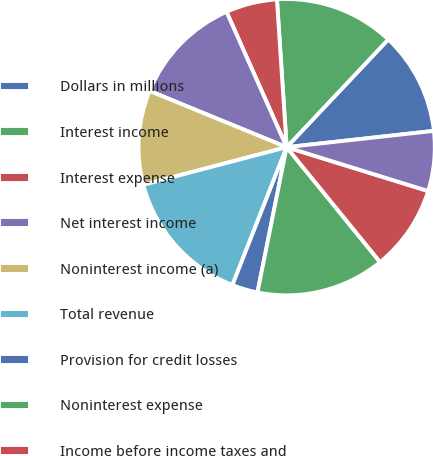Convert chart to OTSL. <chart><loc_0><loc_0><loc_500><loc_500><pie_chart><fcel>Dollars in millions<fcel>Interest income<fcel>Interest expense<fcel>Net interest income<fcel>Noninterest income (a)<fcel>Total revenue<fcel>Provision for credit losses<fcel>Noninterest expense<fcel>Income before income taxes and<fcel>Income taxes<nl><fcel>11.21%<fcel>13.08%<fcel>5.61%<fcel>12.15%<fcel>10.28%<fcel>14.95%<fcel>2.81%<fcel>14.02%<fcel>9.35%<fcel>6.54%<nl></chart> 